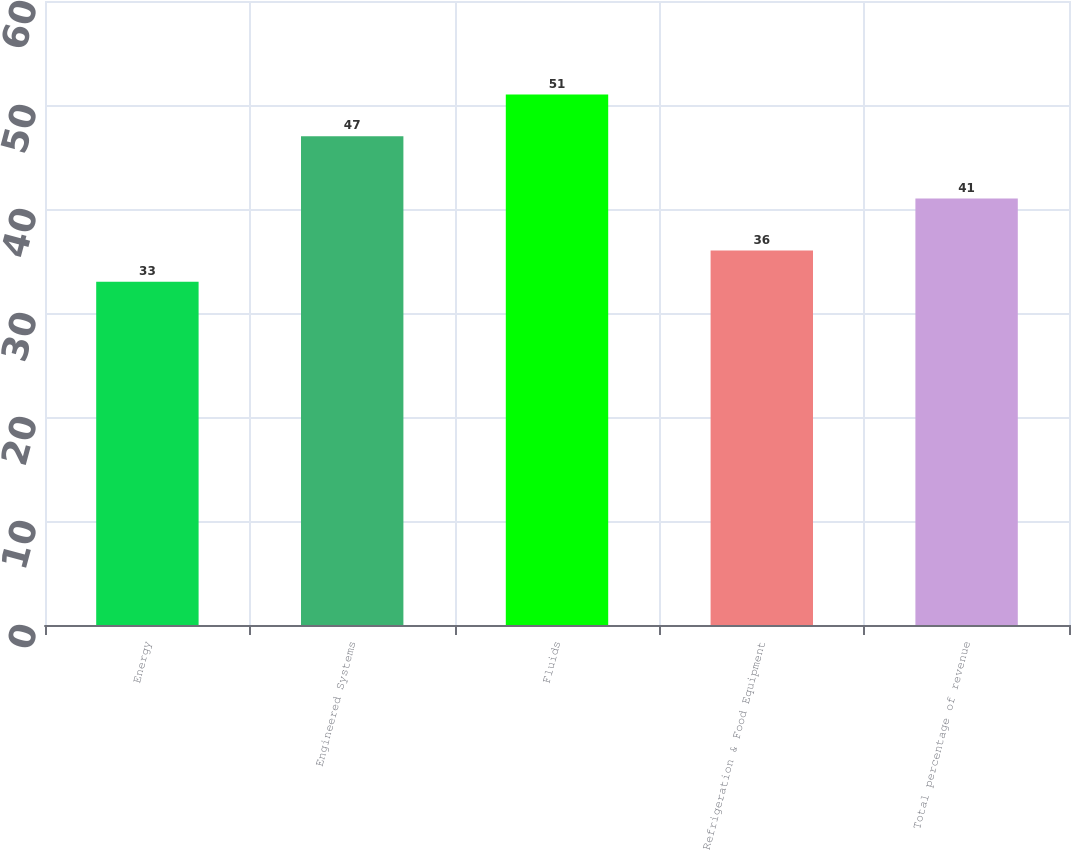<chart> <loc_0><loc_0><loc_500><loc_500><bar_chart><fcel>Energy<fcel>Engineered Systems<fcel>Fluids<fcel>Refrigeration & Food Equipment<fcel>Total percentage of revenue<nl><fcel>33<fcel>47<fcel>51<fcel>36<fcel>41<nl></chart> 